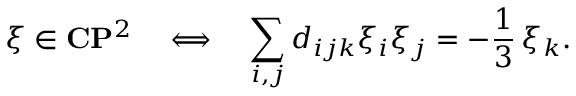<formula> <loc_0><loc_0><loc_500><loc_500>\xi \in { C } { P } ^ { 2 } \quad L o n g l e f t r i g h t a r r o w \quad s u m _ { i , j } d _ { i j k } \xi _ { i } \xi _ { j } = - \frac { 1 } { 3 } \, \xi _ { k } .</formula> 